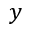Convert formula to latex. <formula><loc_0><loc_0><loc_500><loc_500>y</formula> 